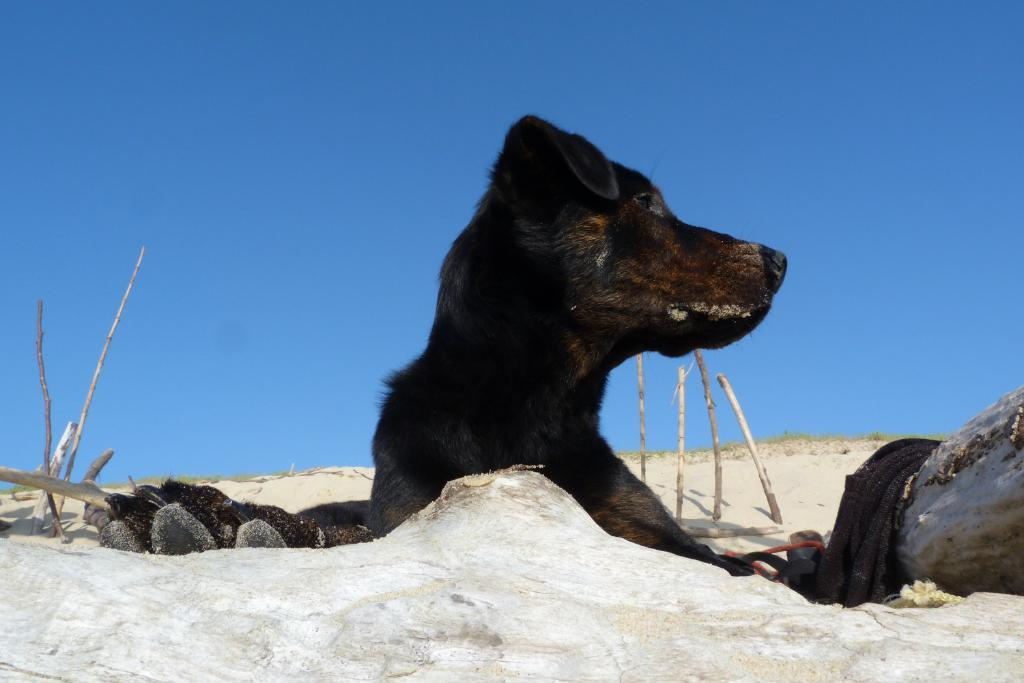What type of animal is in the picture? There is a dog in the picture. What color is the dog? The dog is black in color. What other objects can be seen in the picture? There are wooden poles in the picture. What can be seen in the background of the picture? The sky is visible in the background of the picture. What type of cake is being served on the wooden poles in the picture? There is no cake present in the picture; it features a black dog and wooden poles. How many matches are visible on the dog's paws in the picture? There are no matches present in the picture; it features a black dog and wooden poles. 